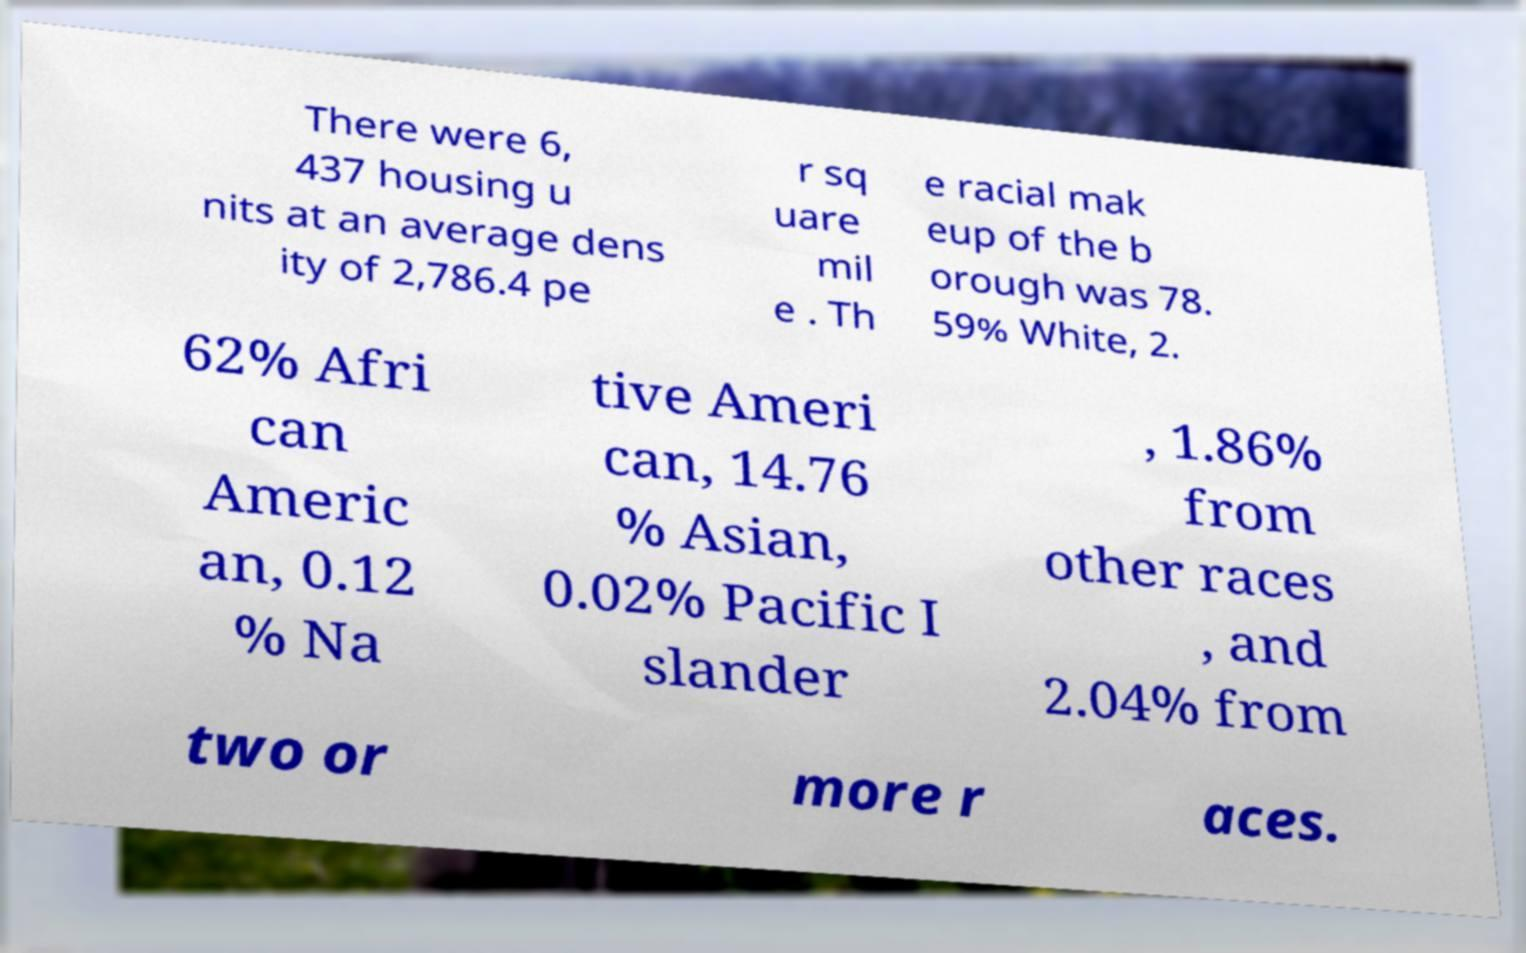Can you accurately transcribe the text from the provided image for me? There were 6, 437 housing u nits at an average dens ity of 2,786.4 pe r sq uare mil e . Th e racial mak eup of the b orough was 78. 59% White, 2. 62% Afri can Americ an, 0.12 % Na tive Ameri can, 14.76 % Asian, 0.02% Pacific I slander , 1.86% from other races , and 2.04% from two or more r aces. 